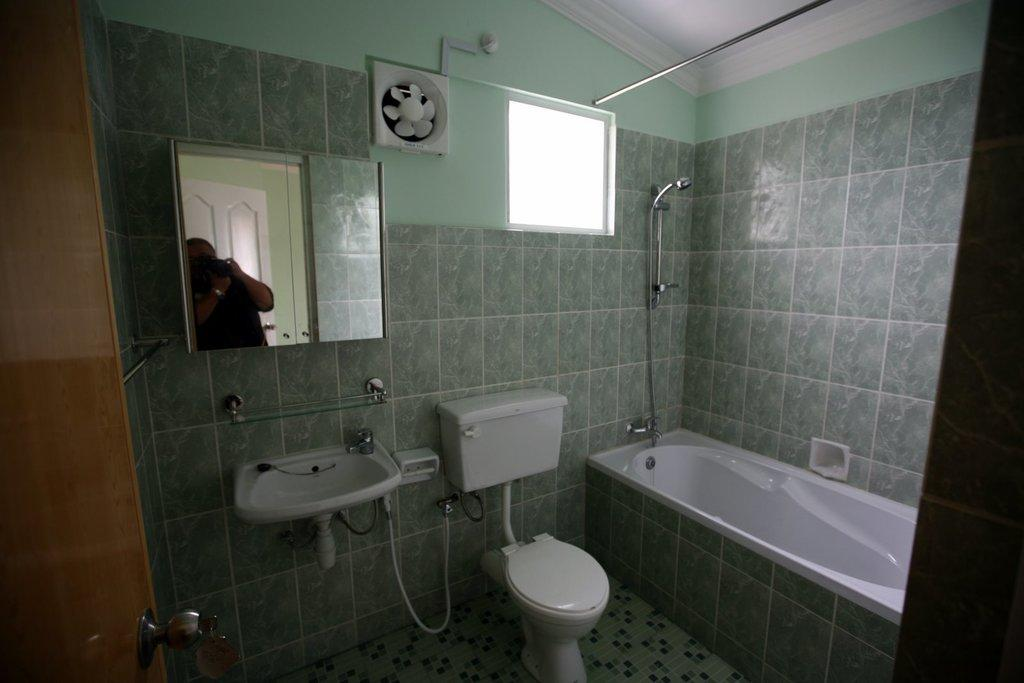What type of fixture is present in the image for bathing? There is a bathtub in the image. What other fixture is present in the image for washing hands? There is a wash basin in the image. What fixture is present in the image for sanitation purposes? There is a toilet in the image. What is attached to the wall in the background of the image? There is a mirror attached to the wall in the background. Whose reflection is visible in the mirror? The person's reflection is visible in the mirror. What type of coil is visible in the image? There is no coil present in the image. What type of leaf is visible in the image? There is no leaf present in the image. 